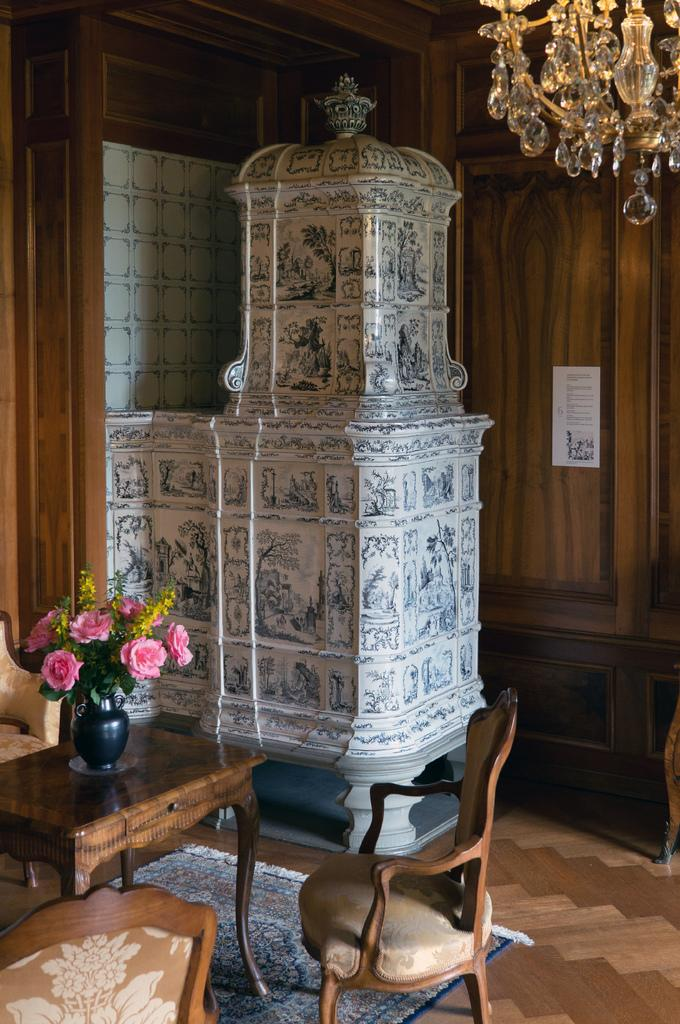What piece of furniture is present in the image? There is a table in the image. What is placed on the table? There is a flower pot on the table. What type of seating is visible in the image? There are chairs in the image. What type of floor covering is present in the image? There is a carpet in the image. What type of lighting fixture is present in the image? There is a chandelier in the image. What is on the wall in the background of the image? There is a poster on the wall in the background. How many pages are in the holiday book on the table? There is no holiday book present in the image; the table has a flower pot on it. What type of low object is present in the image? There is no low object present in the image; the objects mentioned are a table, chairs, a carpet, a chandelier, and a poster on the wall. 